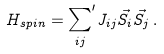<formula> <loc_0><loc_0><loc_500><loc_500>H _ { s p i n } = { \sum _ { i j } } ^ { \prime } J _ { i j } \vec { S _ { i } } \vec { S _ { j } } \, .</formula> 